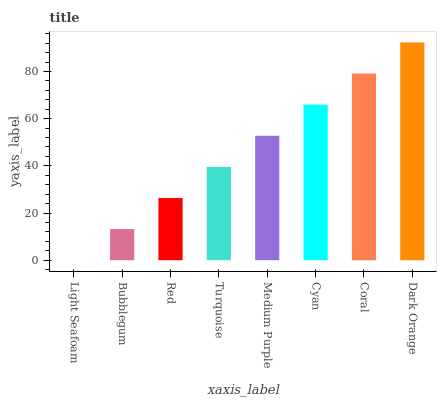Is Light Seafoam the minimum?
Answer yes or no. Yes. Is Dark Orange the maximum?
Answer yes or no. Yes. Is Bubblegum the minimum?
Answer yes or no. No. Is Bubblegum the maximum?
Answer yes or no. No. Is Bubblegum greater than Light Seafoam?
Answer yes or no. Yes. Is Light Seafoam less than Bubblegum?
Answer yes or no. Yes. Is Light Seafoam greater than Bubblegum?
Answer yes or no. No. Is Bubblegum less than Light Seafoam?
Answer yes or no. No. Is Medium Purple the high median?
Answer yes or no. Yes. Is Turquoise the low median?
Answer yes or no. Yes. Is Red the high median?
Answer yes or no. No. Is Medium Purple the low median?
Answer yes or no. No. 